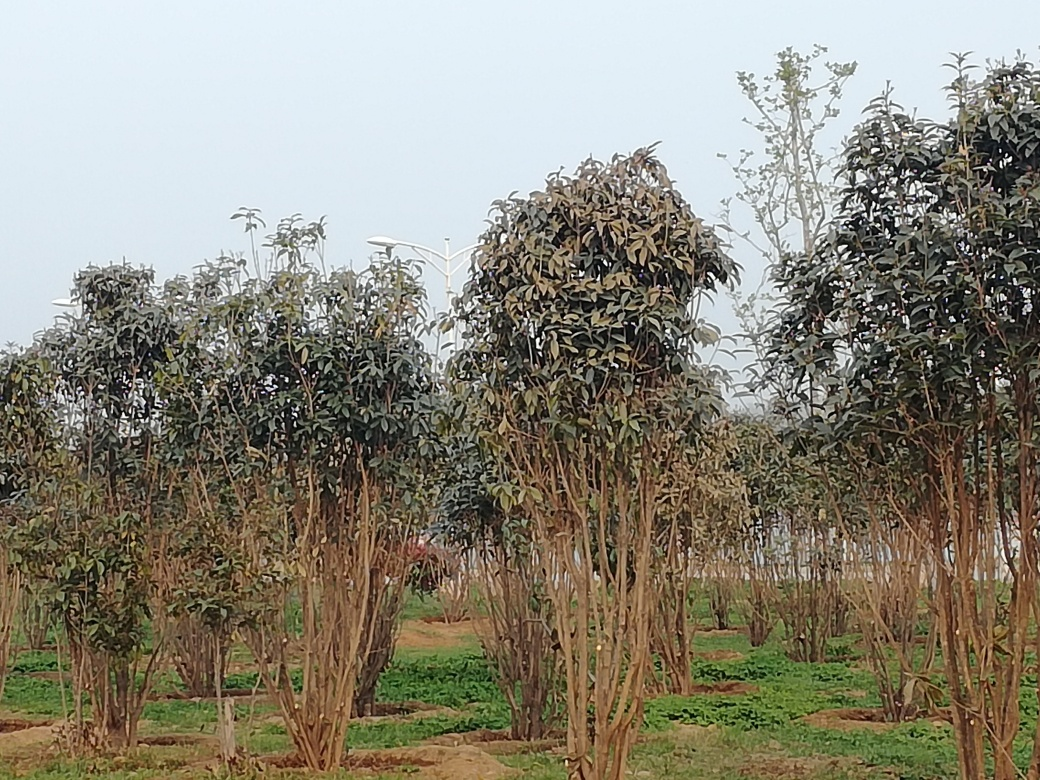What time of day does this image appear to capture? The image seems to have been taken on an overcast day or possibly during the early morning or late afternoon when the light is softer, as indicated by the absence of strong shadows. 